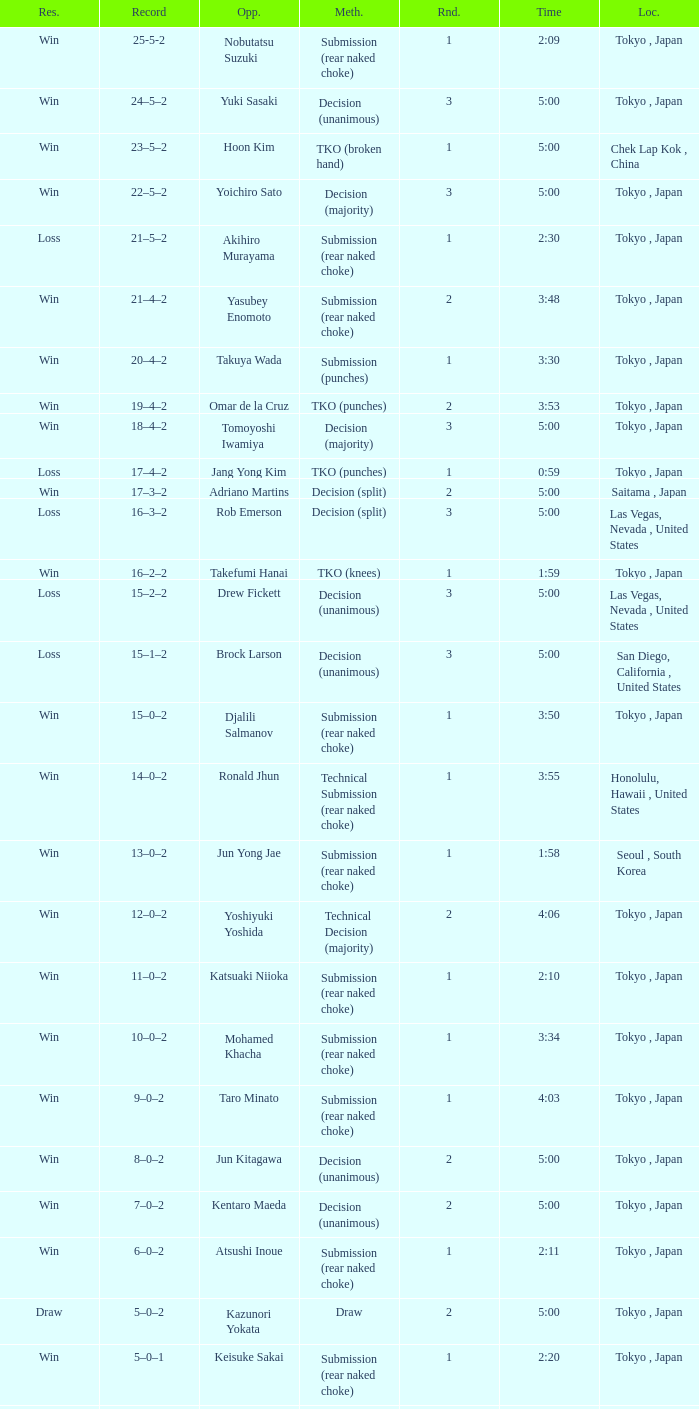What is the total number of rounds when Drew Fickett was the opponent and the time is 5:00? 1.0. 